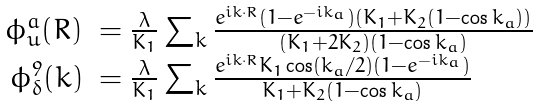<formula> <loc_0><loc_0><loc_500><loc_500>\begin{array} { r l } \phi _ { u } ^ { a } ( R ) & = \frac { \lambda } { K _ { 1 } } \sum _ { k } \frac { e ^ { i k \cdot R } ( 1 - e ^ { - i k _ { a } } ) ( K _ { 1 } + K _ { 2 } ( 1 - \cos k _ { a } ) ) } { ( K _ { 1 } + 2 K _ { 2 } ) ( 1 - \cos k _ { a } ) } \\ \phi _ { \delta } ^ { 9 } ( k ) & = \frac { \lambda } { K _ { 1 } } \sum _ { k } \frac { e ^ { i k \cdot R } K _ { 1 } \cos ( k _ { a } / 2 ) ( 1 - e ^ { - i k _ { a } } ) } { K _ { 1 } + K _ { 2 } ( 1 - \cos k _ { a } ) } \end{array}</formula> 